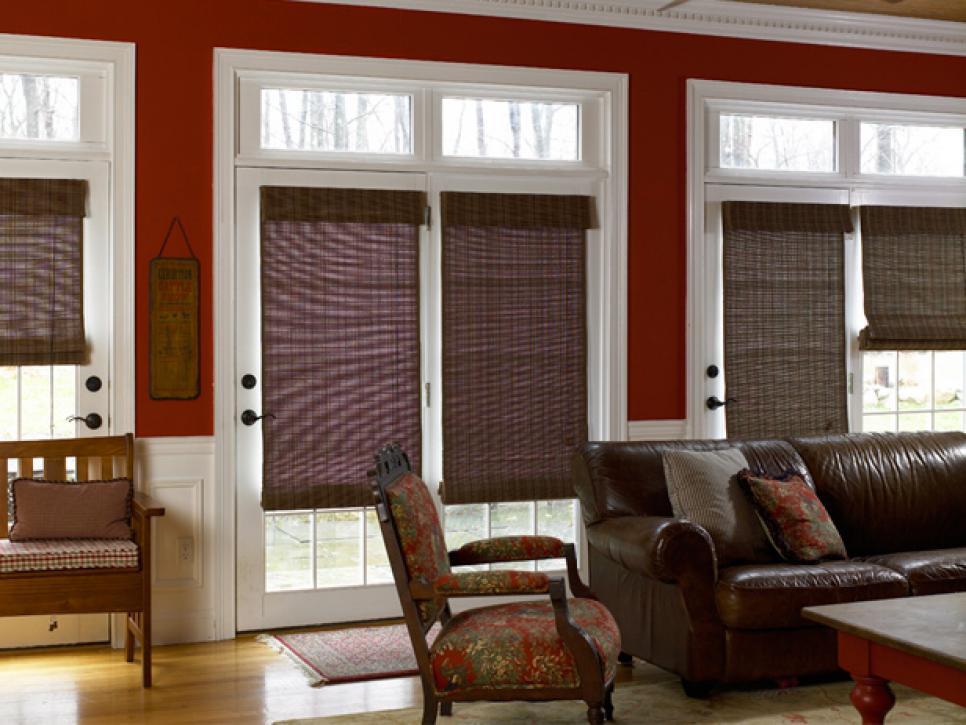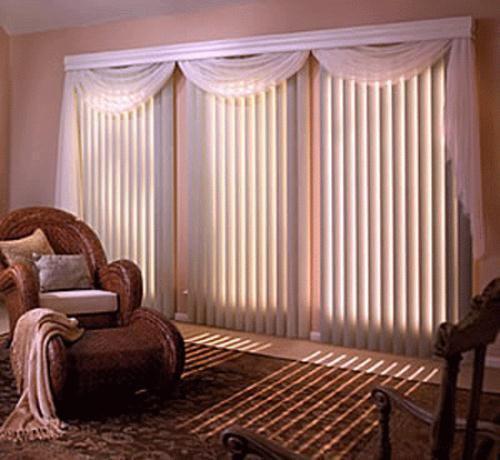The first image is the image on the left, the second image is the image on the right. Analyze the images presented: Is the assertion "An image shows a room with dark-colored walls and at least four brown shades on windows with light-colored frames and no drapes." valid? Answer yes or no. Yes. 